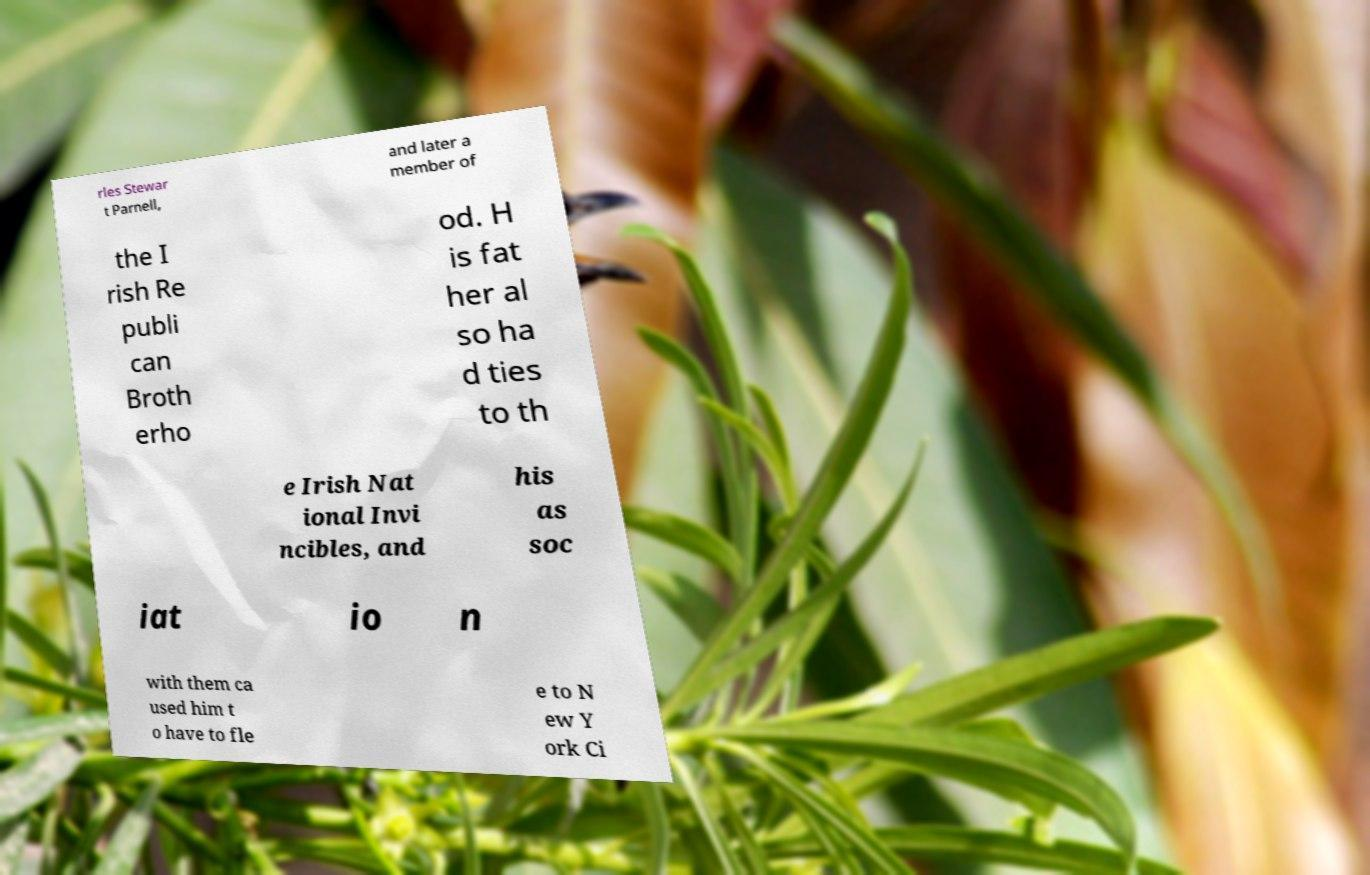What messages or text are displayed in this image? I need them in a readable, typed format. rles Stewar t Parnell, and later a member of the I rish Re publi can Broth erho od. H is fat her al so ha d ties to th e Irish Nat ional Invi ncibles, and his as soc iat io n with them ca used him t o have to fle e to N ew Y ork Ci 